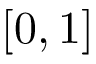<formula> <loc_0><loc_0><loc_500><loc_500>[ 0 , 1 ]</formula> 